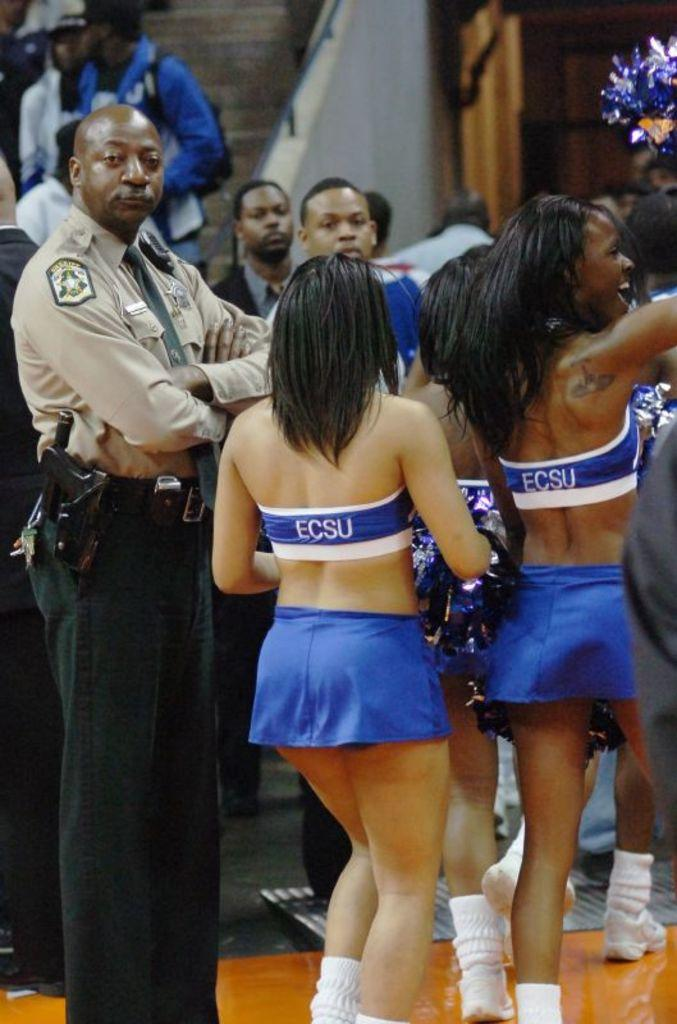<image>
Provide a brief description of the given image. ECSU cheerleaders are on a basketball court during a game. 